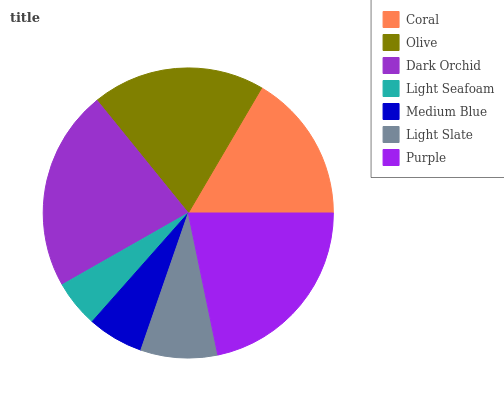Is Light Seafoam the minimum?
Answer yes or no. Yes. Is Dark Orchid the maximum?
Answer yes or no. Yes. Is Olive the minimum?
Answer yes or no. No. Is Olive the maximum?
Answer yes or no. No. Is Olive greater than Coral?
Answer yes or no. Yes. Is Coral less than Olive?
Answer yes or no. Yes. Is Coral greater than Olive?
Answer yes or no. No. Is Olive less than Coral?
Answer yes or no. No. Is Coral the high median?
Answer yes or no. Yes. Is Coral the low median?
Answer yes or no. Yes. Is Dark Orchid the high median?
Answer yes or no. No. Is Light Slate the low median?
Answer yes or no. No. 